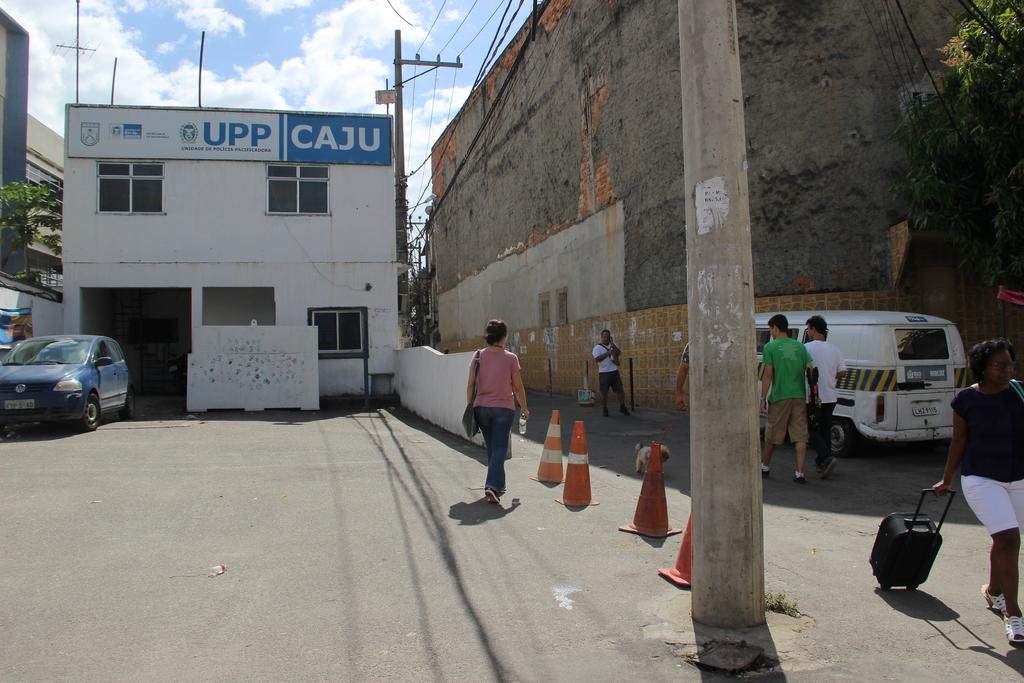<image>
Describe the image concisely. Building with a white and blue sign which says UPP CAJU. 